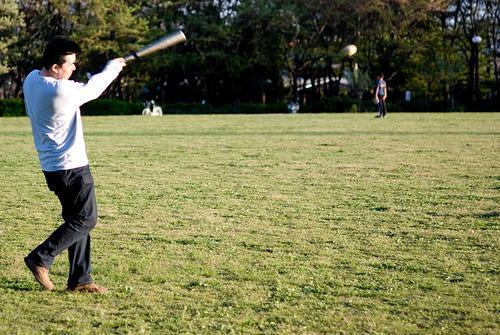How many people playing baseball?
Give a very brief answer. 1. How many stacks of phone books are visible?
Give a very brief answer. 0. 